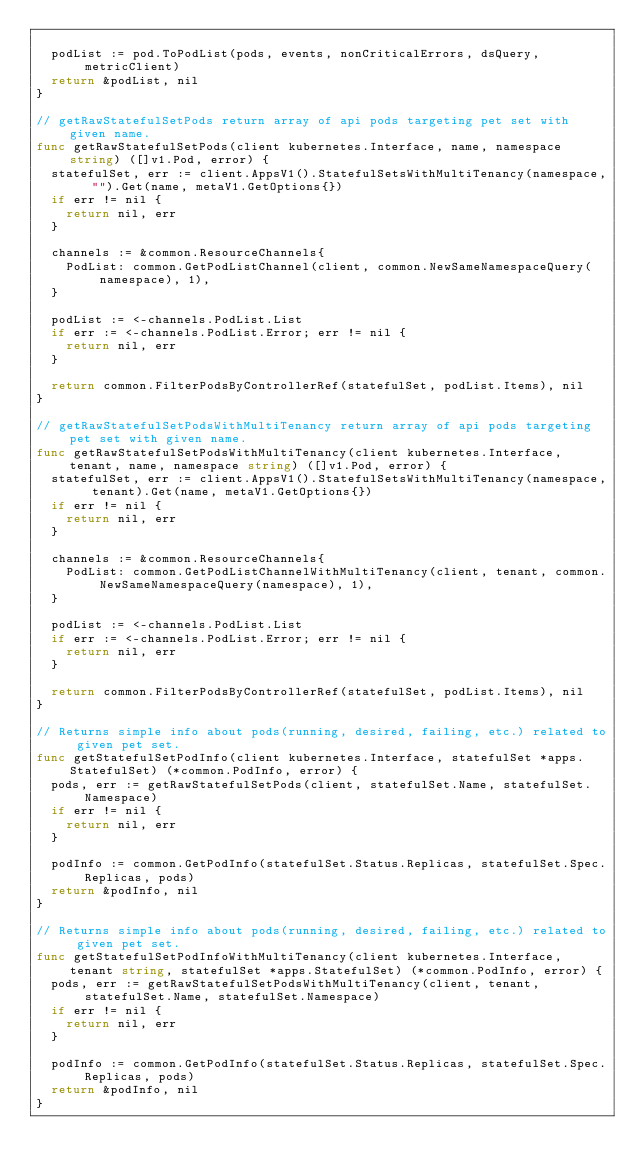Convert code to text. <code><loc_0><loc_0><loc_500><loc_500><_Go_>
	podList := pod.ToPodList(pods, events, nonCriticalErrors, dsQuery, metricClient)
	return &podList, nil
}

// getRawStatefulSetPods return array of api pods targeting pet set with given name.
func getRawStatefulSetPods(client kubernetes.Interface, name, namespace string) ([]v1.Pod, error) {
	statefulSet, err := client.AppsV1().StatefulSetsWithMultiTenancy(namespace, "").Get(name, metaV1.GetOptions{})
	if err != nil {
		return nil, err
	}

	channels := &common.ResourceChannels{
		PodList: common.GetPodListChannel(client, common.NewSameNamespaceQuery(namespace), 1),
	}

	podList := <-channels.PodList.List
	if err := <-channels.PodList.Error; err != nil {
		return nil, err
	}

	return common.FilterPodsByControllerRef(statefulSet, podList.Items), nil
}

// getRawStatefulSetPodsWithMultiTenancy return array of api pods targeting pet set with given name.
func getRawStatefulSetPodsWithMultiTenancy(client kubernetes.Interface, tenant, name, namespace string) ([]v1.Pod, error) {
	statefulSet, err := client.AppsV1().StatefulSetsWithMultiTenancy(namespace, tenant).Get(name, metaV1.GetOptions{})
	if err != nil {
		return nil, err
	}

	channels := &common.ResourceChannels{
		PodList: common.GetPodListChannelWithMultiTenancy(client, tenant, common.NewSameNamespaceQuery(namespace), 1),
	}

	podList := <-channels.PodList.List
	if err := <-channels.PodList.Error; err != nil {
		return nil, err
	}

	return common.FilterPodsByControllerRef(statefulSet, podList.Items), nil
}

// Returns simple info about pods(running, desired, failing, etc.) related to given pet set.
func getStatefulSetPodInfo(client kubernetes.Interface, statefulSet *apps.StatefulSet) (*common.PodInfo, error) {
	pods, err := getRawStatefulSetPods(client, statefulSet.Name, statefulSet.Namespace)
	if err != nil {
		return nil, err
	}

	podInfo := common.GetPodInfo(statefulSet.Status.Replicas, statefulSet.Spec.Replicas, pods)
	return &podInfo, nil
}

// Returns simple info about pods(running, desired, failing, etc.) related to given pet set.
func getStatefulSetPodInfoWithMultiTenancy(client kubernetes.Interface, tenant string, statefulSet *apps.StatefulSet) (*common.PodInfo, error) {
	pods, err := getRawStatefulSetPodsWithMultiTenancy(client, tenant, statefulSet.Name, statefulSet.Namespace)
	if err != nil {
		return nil, err
	}

	podInfo := common.GetPodInfo(statefulSet.Status.Replicas, statefulSet.Spec.Replicas, pods)
	return &podInfo, nil
}
</code> 